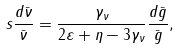<formula> <loc_0><loc_0><loc_500><loc_500>s \frac { d \bar { \nu } } { \bar { \nu } } = \frac { \gamma _ { \nu } } { 2 \varepsilon + \eta - 3 \gamma _ { \nu } } \frac { d \bar { g } } { \bar { g } } ,</formula> 